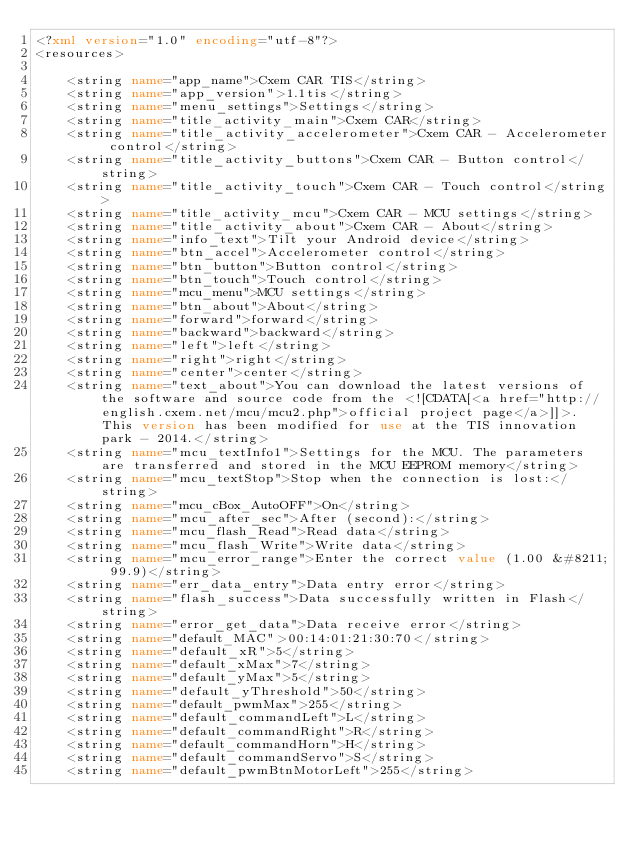<code> <loc_0><loc_0><loc_500><loc_500><_XML_><?xml version="1.0" encoding="utf-8"?>
<resources>

    <string name="app_name">Cxem CAR TIS</string>
    <string name="app_version">1.1tis</string>
    <string name="menu_settings">Settings</string>
    <string name="title_activity_main">Cxem CAR</string>
    <string name="title_activity_accelerometer">Cxem CAR - Accelerometer control</string>
    <string name="title_activity_buttons">Cxem CAR - Button control</string>
    <string name="title_activity_touch">Cxem CAR - Touch control</string>
    <string name="title_activity_mcu">Cxem CAR - MCU settings</string>
    <string name="title_activity_about">Cxem CAR - About</string>
    <string name="info_text">Tilt your Android device</string>
    <string name="btn_accel">Accelerometer control</string>
    <string name="btn_button">Button control</string>
    <string name="btn_touch">Touch control</string>
    <string name="mcu_menu">MCU settings</string>
    <string name="btn_about">About</string>
    <string name="forward">forward</string>
    <string name="backward">backward</string>
    <string name="left">left</string>
    <string name="right">right</string>
    <string name="center">center</string>
    <string name="text_about">You can download the latest versions of the software and source code from the <![CDATA[<a href="http://english.cxem.net/mcu/mcu2.php">official project page</a>]]>. This version has been modified for use at the TIS innovation park - 2014.</string>
    <string name="mcu_textInfo1">Settings for the MCU. The parameters are transferred and stored in the MCU EEPROM memory</string>
    <string name="mcu_textStop">Stop when the connection is lost:</string>
    <string name="mcu_cBox_AutoOFF">On</string>
    <string name="mcu_after_sec">After (second):</string>
    <string name="mcu_flash_Read">Read data</string>
    <string name="mcu_flash_Write">Write data</string>
    <string name="mcu_error_range">Enter the correct value (1.00 &#8211; 99.9)</string>
    <string name="err_data_entry">Data entry error</string>
    <string name="flash_success">Data successfully written in Flash</string>
    <string name="error_get_data">Data receive error</string>
    <string name="default_MAC">00:14:01:21:30:70</string>
    <string name="default_xR">5</string>
    <string name="default_xMax">7</string>
    <string name="default_yMax">5</string>
    <string name="default_yThreshold">50</string>
    <string name="default_pwmMax">255</string>
    <string name="default_commandLeft">L</string>
    <string name="default_commandRight">R</string>
    <string name="default_commandHorn">H</string>
    <string name="default_commandServo">S</string>
    <string name="default_pwmBtnMotorLeft">255</string></code> 